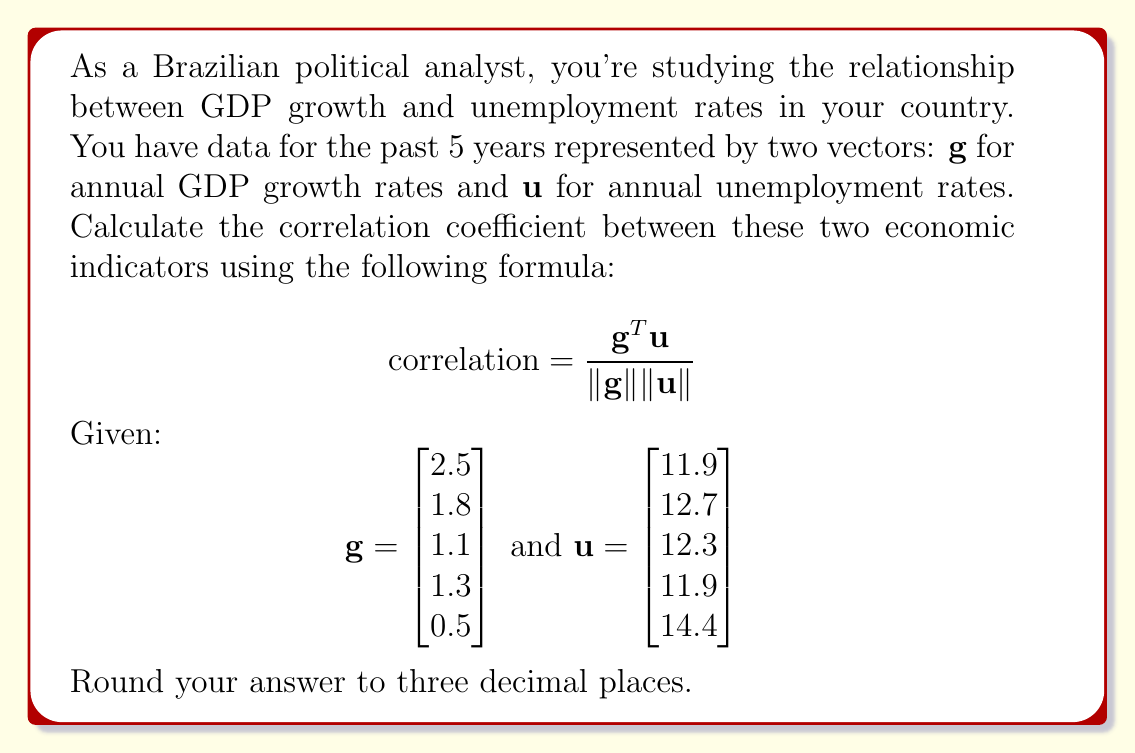Help me with this question. To calculate the correlation coefficient, we'll follow these steps:

1. Calculate $\mathbf{g}^T \mathbf{u}$:
   $$\mathbf{g}^T \mathbf{u} = [2.5 \quad 1.8 \quad 1.1 \quad 1.3 \quad 0.5] \begin{bmatrix} 11.9 \\ 12.7 \\ 12.3 \\ 11.9 \\ 14.4 \end{bmatrix} = 2.5(11.9) + 1.8(12.7) + 1.1(12.3) + 1.3(11.9) + 0.5(14.4) = 83.72$$

2. Calculate $\|\mathbf{g}\|$:
   $$\|\mathbf{g}\| = \sqrt{2.5^2 + 1.8^2 + 1.1^2 + 1.3^2 + 0.5^2} = \sqrt{14.84} = 3.853$$

3. Calculate $\|\mathbf{u}\|$:
   $$\|\mathbf{u}\| = \sqrt{11.9^2 + 12.7^2 + 12.3^2 + 11.9^2 + 14.4^2} = \sqrt{796.28} = 28.218$$

4. Apply the correlation formula:
   $$\text{correlation} = \frac{\mathbf{g}^T \mathbf{u}}{\|\mathbf{g}\| \|\mathbf{u}\|} = \frac{83.72}{3.853 \times 28.218} = \frac{83.72}{108.684} = 0.770$$

5. Round to three decimal places:
   $$\text{correlation} \approx 0.770$$
Answer: 0.770 